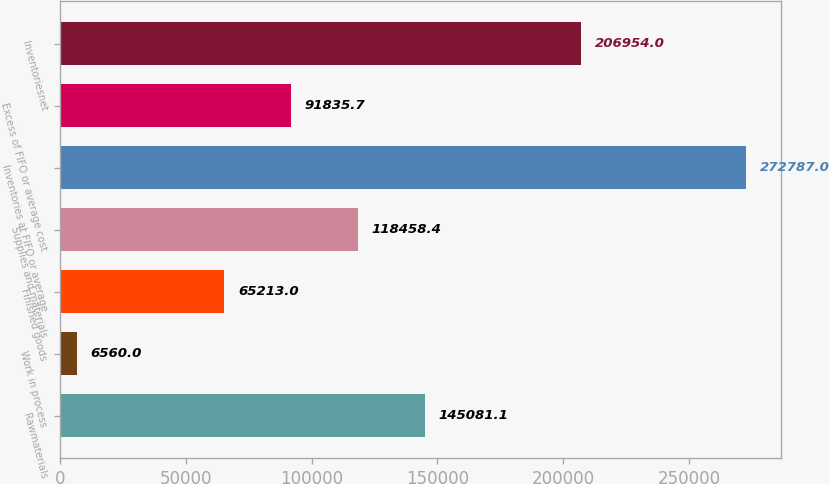Convert chart to OTSL. <chart><loc_0><loc_0><loc_500><loc_500><bar_chart><fcel>Rawmaterials<fcel>Work in process<fcel>Finished goods<fcel>Supplies and materials<fcel>Inventories at FIFO or average<fcel>Excess of FIFO or average cost<fcel>Inventoriesnet<nl><fcel>145081<fcel>6560<fcel>65213<fcel>118458<fcel>272787<fcel>91835.7<fcel>206954<nl></chart> 